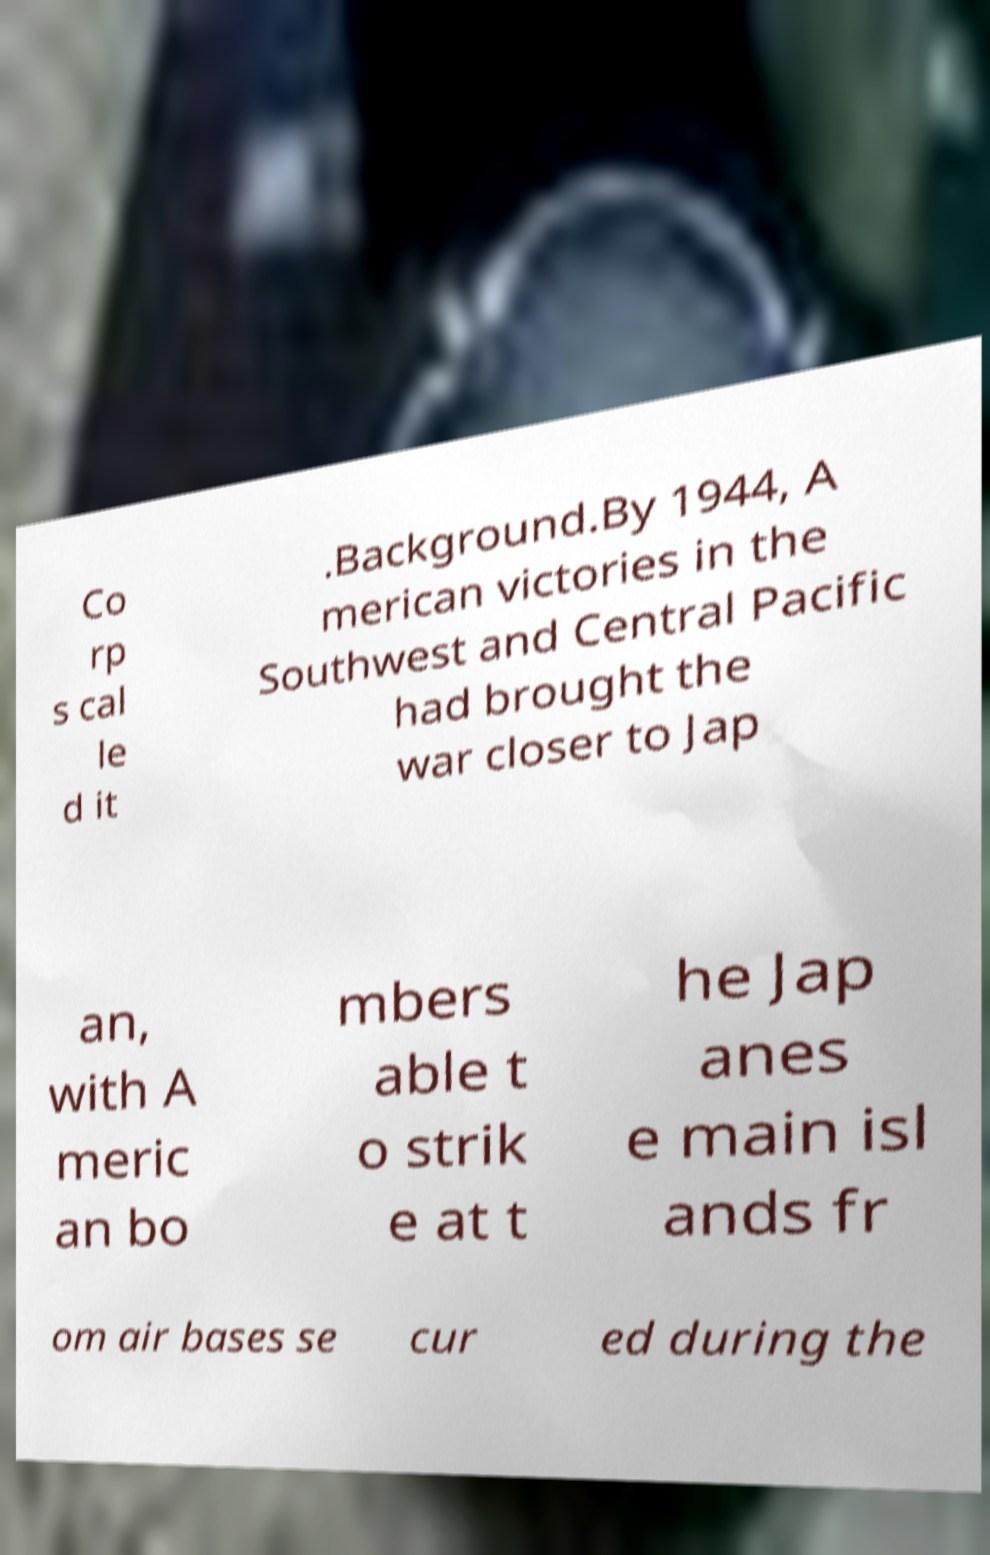Can you accurately transcribe the text from the provided image for me? Co rp s cal le d it .Background.By 1944, A merican victories in the Southwest and Central Pacific had brought the war closer to Jap an, with A meric an bo mbers able t o strik e at t he Jap anes e main isl ands fr om air bases se cur ed during the 